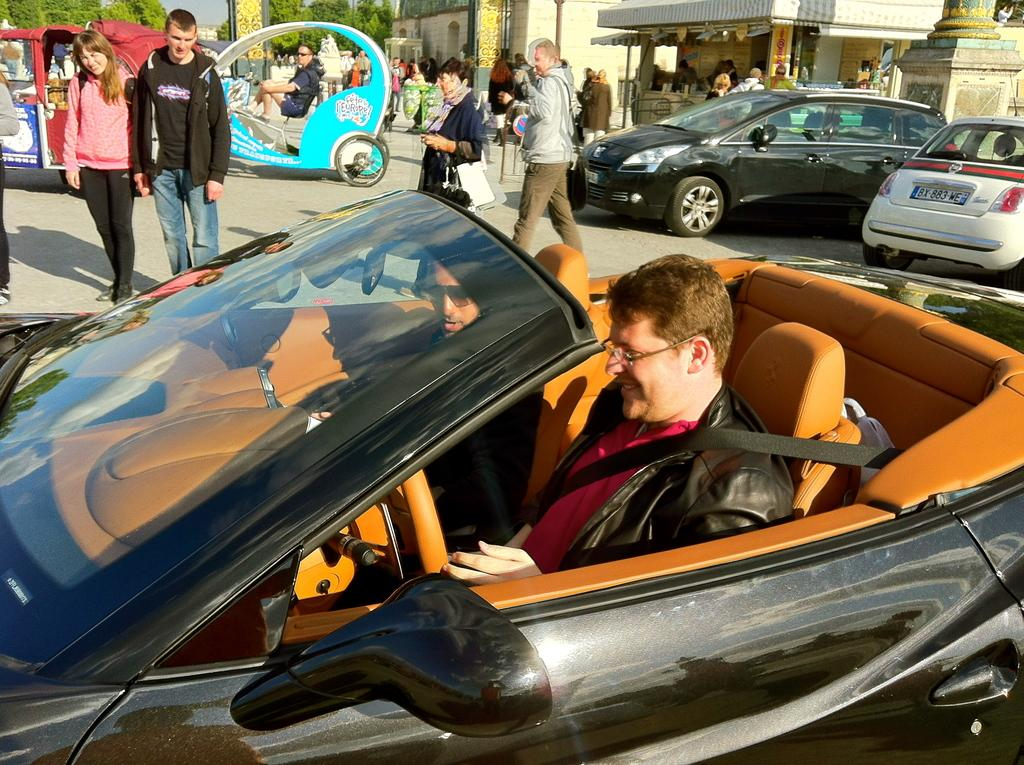What can be seen on the road in the image? There are vehicles and a group of people on the road in the image. Can you describe the occupants of one of the vehicles? Two persons are sitting inside a vehicle in the image. What else is visible in the image besides the road? There are buildings visible in the image. What type of natural elements can be seen in the background of the image? Trees are present in the background of the image. What type of wealth is being displayed by the goose in the image? There is no goose present in the image, so it is not possible to determine if any wealth is being displayed. What operation is being performed by the vehicles in the image? The vehicles in the image are simply driving on the road, and no specific operation is being performed. 